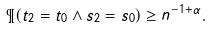Convert formula to latex. <formula><loc_0><loc_0><loc_500><loc_500>\P ( t _ { 2 } = t _ { 0 } \wedge s _ { 2 } = s _ { 0 } ) \geq n ^ { - 1 + \alpha } .</formula> 